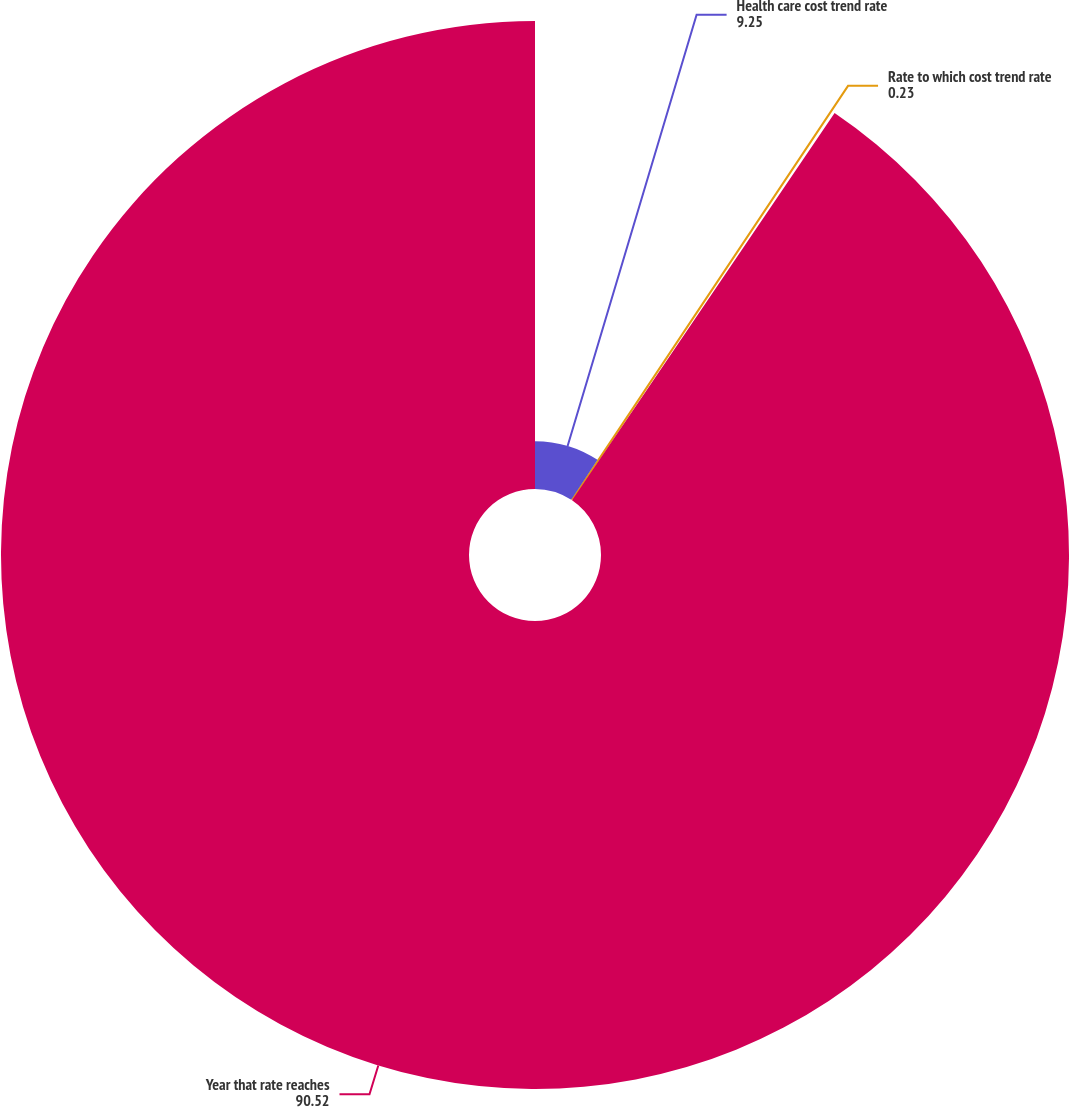Convert chart to OTSL. <chart><loc_0><loc_0><loc_500><loc_500><pie_chart><fcel>Health care cost trend rate<fcel>Rate to which cost trend rate<fcel>Year that rate reaches<nl><fcel>9.25%<fcel>0.23%<fcel>90.52%<nl></chart> 